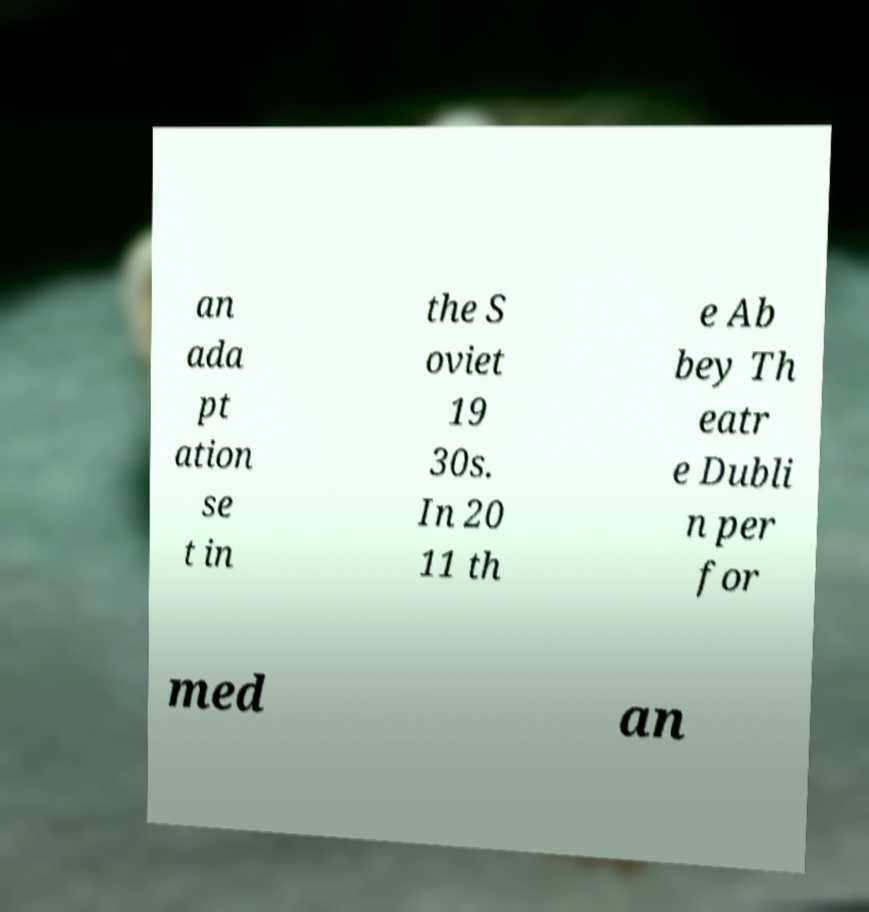Can you accurately transcribe the text from the provided image for me? an ada pt ation se t in the S oviet 19 30s. In 20 11 th e Ab bey Th eatr e Dubli n per for med an 